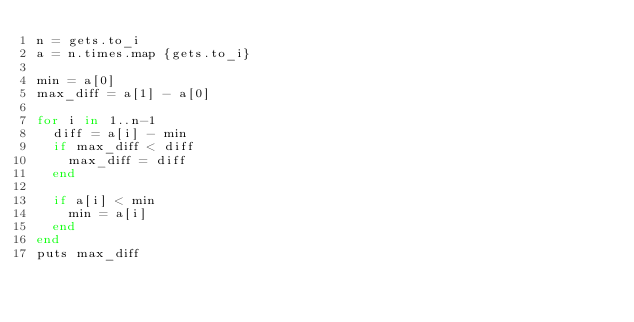Convert code to text. <code><loc_0><loc_0><loc_500><loc_500><_Ruby_>n = gets.to_i
a = n.times.map {gets.to_i}

min = a[0]
max_diff = a[1] - a[0]

for i in 1..n-1
  diff = a[i] - min
  if max_diff < diff
    max_diff = diff
  end

  if a[i] < min
    min = a[i]
  end
end
puts max_diff
</code> 